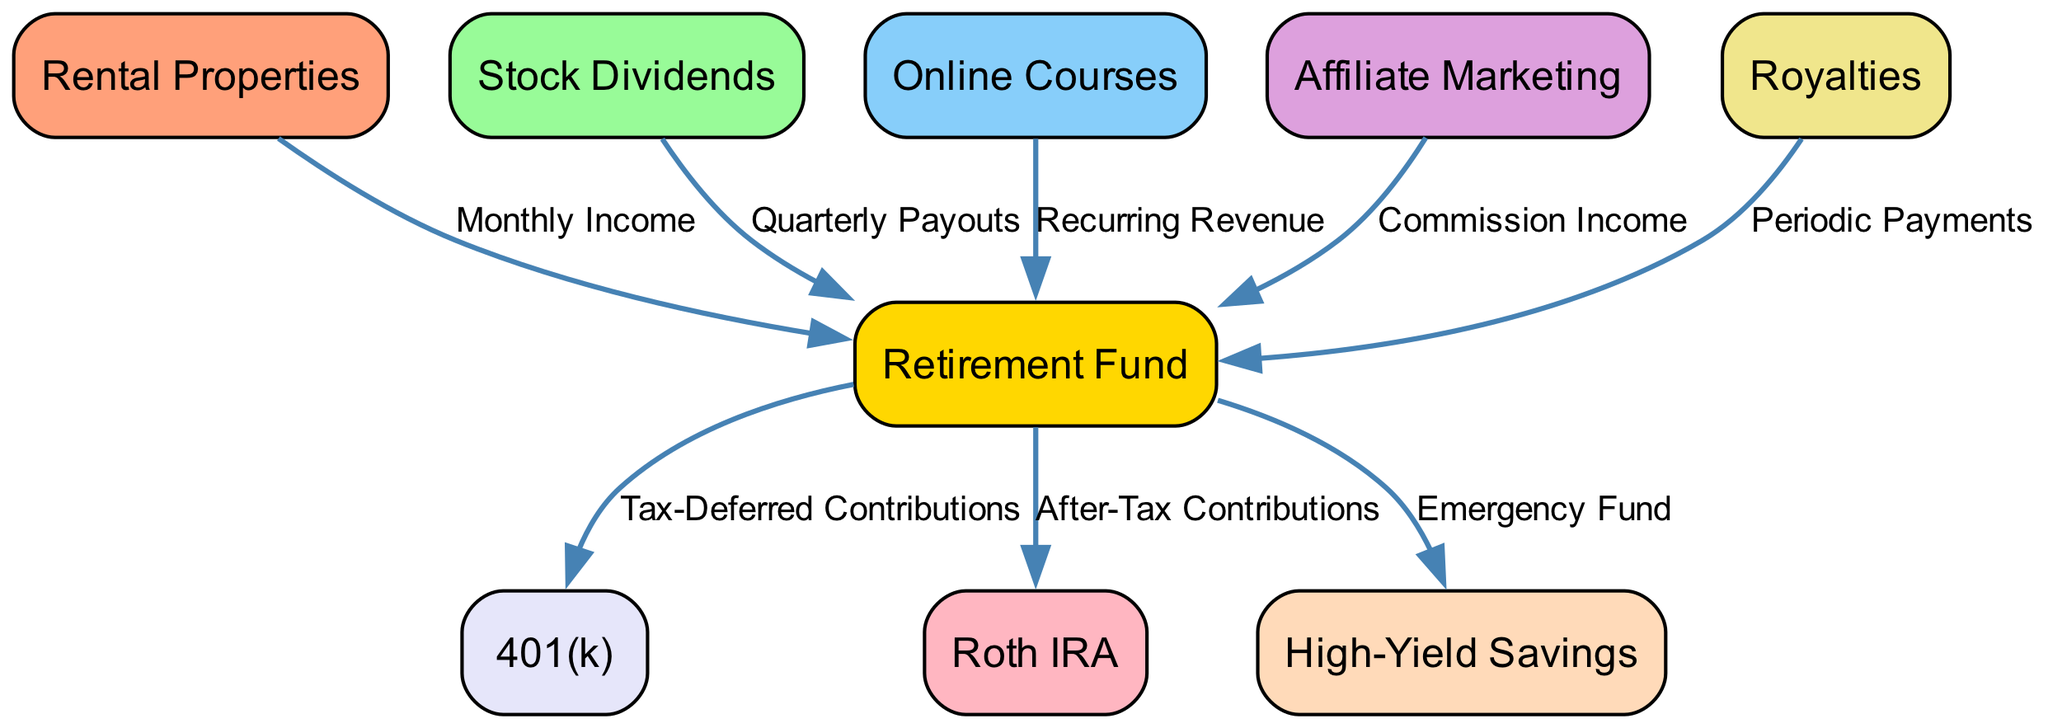What are the nodes present in the diagram? The nodes are the individual sources of passive income and financial instruments depicted in the diagram. They include Rental Properties, Stock Dividends, Online Courses, Affiliate Marketing, Royalties, 401(k), Roth IRA, High-Yield Savings, and Retirement Fund.
Answer: Rental Properties, Stock Dividends, Online Courses, Affiliate Marketing, Royalties, 401(k), Roth IRA, High-Yield Savings, Retirement Fund How many edges connect to the Retirement Fund? Count the number of edges leading into the Retirement Fund node. According to the diagram, there are five sources of income that provide direct contributions to the Retirement Fund.
Answer: Five What type of income does Rental Properties contribute? The edge labeled from Rental Properties to Retirement Fund indicates that it contributes Monthly Income. This specific label defines the nature of the contribution from this node.
Answer: Monthly Income Which nodes directly contribute to the Retirement Fund? Examine the incoming edges to the Retirement Fund to identify all nodes that lead to it. These nodes are Rental Properties, Stock Dividends, Online Courses, Affiliate Marketing, and Royalties.
Answer: Rental Properties, Stock Dividends, Online Courses, Affiliate Marketing, Royalties What type of contributions does the Retirement Fund make to the 401(k)? The edge from Retirement Fund to 401(k) is labeled Tax-Deferred Contributions, indicating that the type of contribution made is tax-deferred. This is the method through which the Retirement Fund influences the 401(k).
Answer: Tax-Deferred Contributions Which passive income source yields a recurring revenue? Looking at the edge from Online Courses to Retirement Fund, the label specifies that this source yields Recurring Revenue, distinguishing it from other types of income.
Answer: Recurring Revenue What is the purpose of High-Yield Savings in the graph? The edge connecting the Retirement Fund to High-Yield Savings is labeled Emergency Fund, clarifying that its purpose is to serve as a reserve for emergencies.
Answer: Emergency Fund Which two financial instruments are influenced by the Retirement Fund? The outgoing edges from Retirement Fund lead to 401(k) and Roth IRA. Analyzing these connections shows the two financial instruments that are impacted by it.
Answer: 401(k) and Roth IRA What is the common connection among Rental Properties, Stock Dividends, Online Courses, Affiliate Marketing, and Royalties? All these nodes are connected to the Retirement Fund, indicating that they are sources of passive income that collectively feed into retirement savings.
Answer: They connect to Retirement Fund 